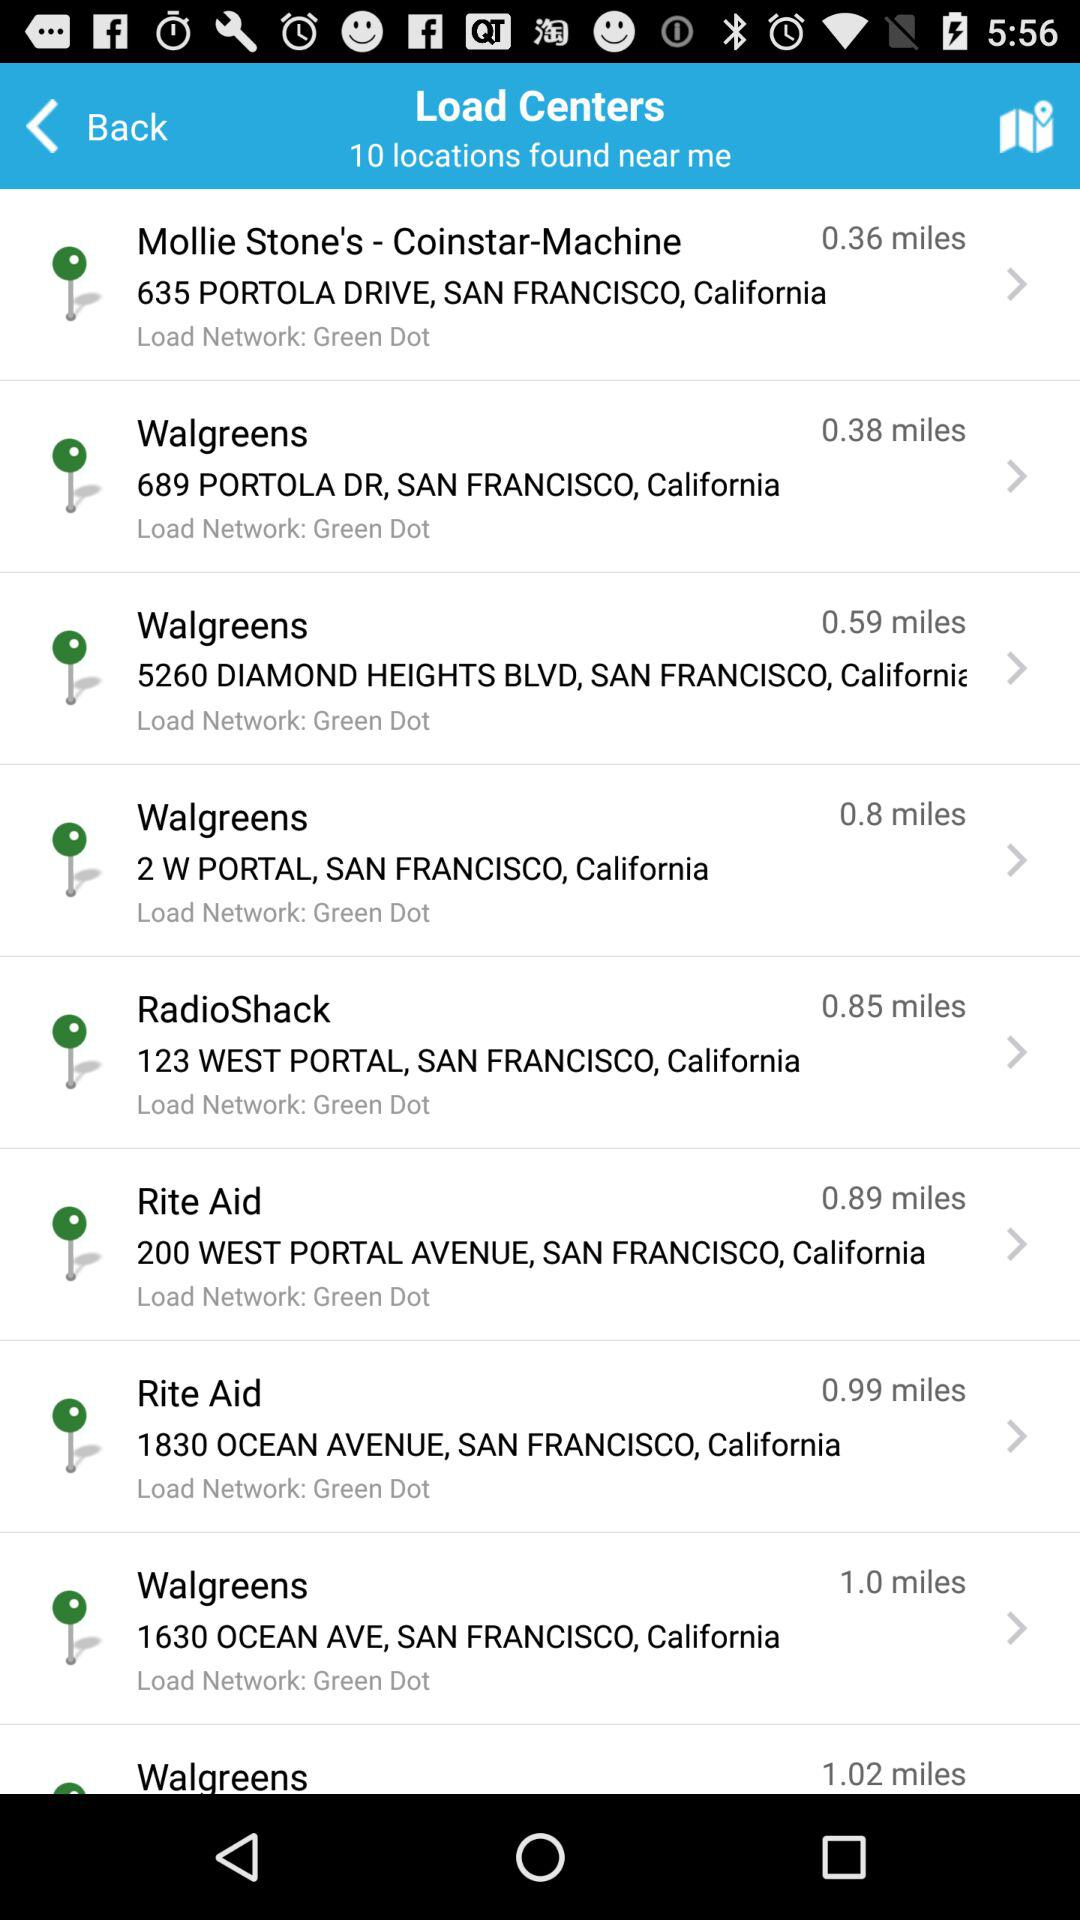How many locations are found nearby? The number of locations found nearby is 10. 